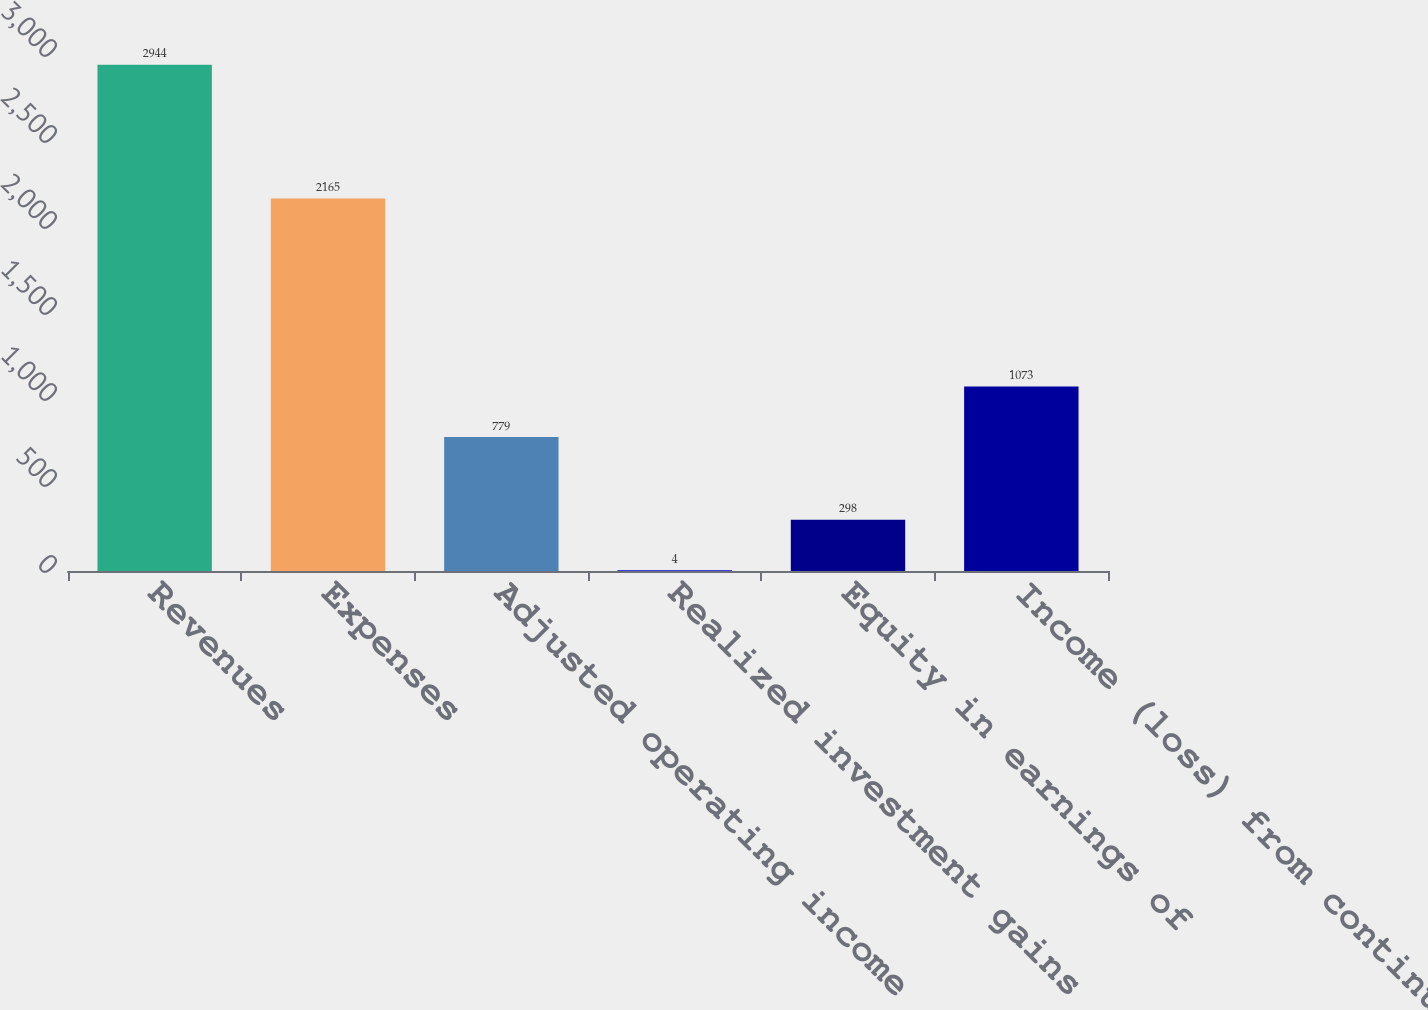Convert chart to OTSL. <chart><loc_0><loc_0><loc_500><loc_500><bar_chart><fcel>Revenues<fcel>Expenses<fcel>Adjusted operating income<fcel>Realized investment gains<fcel>Equity in earnings of<fcel>Income (loss) from continuing<nl><fcel>2944<fcel>2165<fcel>779<fcel>4<fcel>298<fcel>1073<nl></chart> 